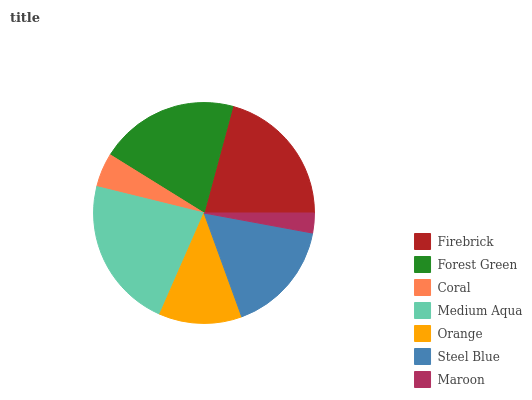Is Maroon the minimum?
Answer yes or no. Yes. Is Medium Aqua the maximum?
Answer yes or no. Yes. Is Forest Green the minimum?
Answer yes or no. No. Is Forest Green the maximum?
Answer yes or no. No. Is Firebrick greater than Forest Green?
Answer yes or no. Yes. Is Forest Green less than Firebrick?
Answer yes or no. Yes. Is Forest Green greater than Firebrick?
Answer yes or no. No. Is Firebrick less than Forest Green?
Answer yes or no. No. Is Steel Blue the high median?
Answer yes or no. Yes. Is Steel Blue the low median?
Answer yes or no. Yes. Is Orange the high median?
Answer yes or no. No. Is Medium Aqua the low median?
Answer yes or no. No. 